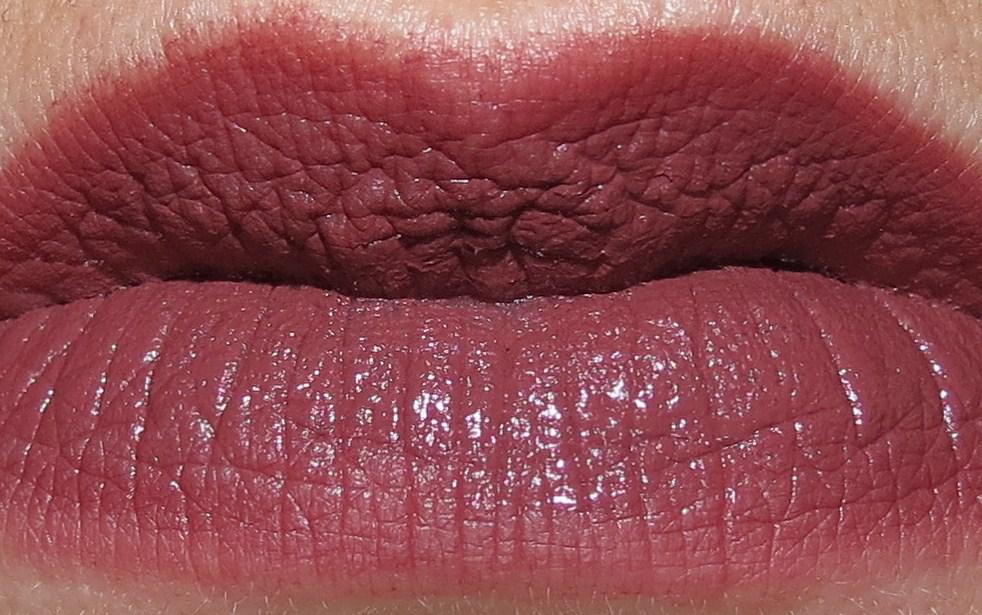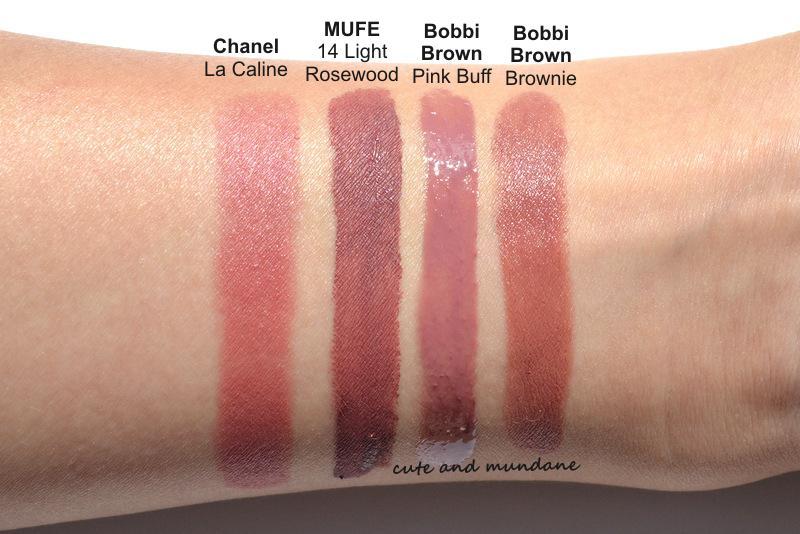The first image is the image on the left, the second image is the image on the right. Given the left and right images, does the statement "A lipstick swatch is shown on a person's lip in both images." hold true? Answer yes or no. No. The first image is the image on the left, the second image is the image on the right. Considering the images on both sides, is "The right image contains human lips with lipstick on them." valid? Answer yes or no. No. 